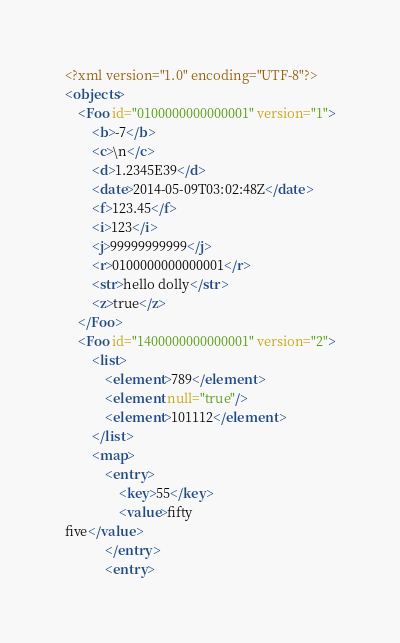Convert code to text. <code><loc_0><loc_0><loc_500><loc_500><_XML_><?xml version="1.0" encoding="UTF-8"?>
<objects>
    <Foo id="0100000000000001" version="1">
        <b>-7</b>
        <c>\n</c>
        <d>1.2345E39</d>
        <date>2014-05-09T03:02:48Z</date>
        <f>123.45</f>
        <i>123</i>
        <j>99999999999</j>
        <r>0100000000000001</r>
        <str>hello dolly</str>
        <z>true</z>
    </Foo>
    <Foo id="1400000000000001" version="2">
        <list>
            <element>789</element>
            <element null="true"/>
            <element>101112</element>
        </list>
        <map>
            <entry>
                <key>55</key>
                <value>fifty
five</value>
            </entry>
            <entry></code> 